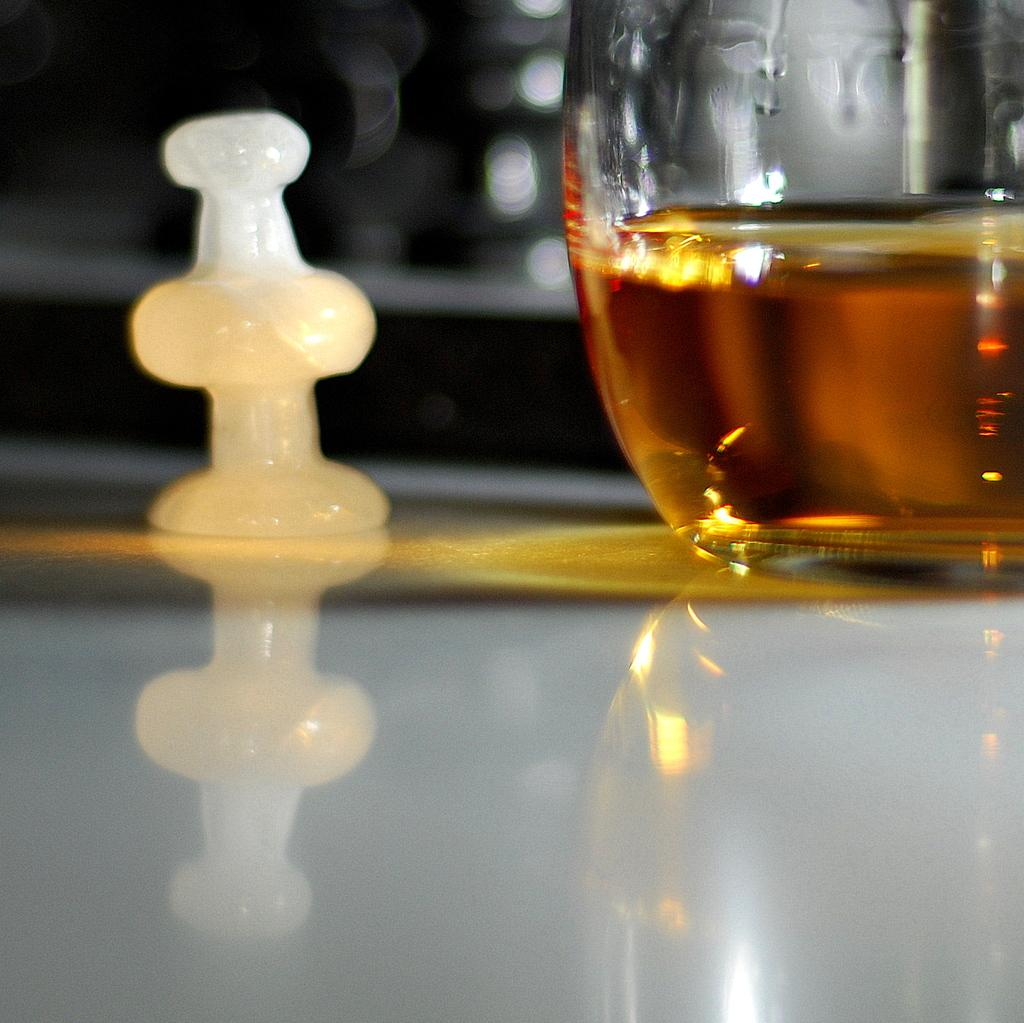What is present on the table in the image? There is a wine glass in the image, and it is placed on a table. What else can be seen in the image besides the wine glass? There is a white color chess coin in the image. What type of floor can be seen in the image? There is no information about the floor in the image, as the focus is on the wine glass and chess coin. 